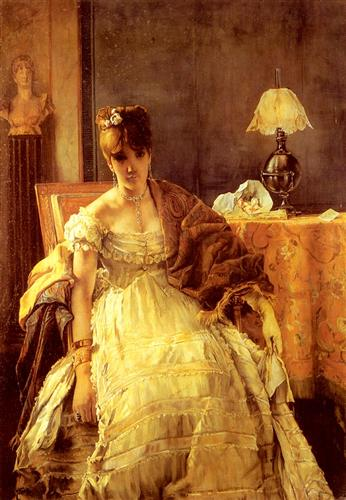Imagine a narrative for the woman in the painting. What might her story be? Evelyn, a young noblewoman of the late 19th century, sat in the familiar comfort of her drawing-room, absorbed in silent contemplation. The ornate dress she wore was not just a symbol of her wealth but of her standing within the intricate social tapestry of her time. As the daylight dimmed and the golden glow of the lamp filled the room, memories of traveling through Europe, meeting artists, philosophers, and even royalty, gently flowed through her mind. She was a figure caught at the crossroads of duty and personal longing, each fold of her dress, each piece of jewelry, a testament to a life lived amidst grandeur but also profound introspection. Evelyn's poised posture, the luxurious surroundings, and the reserved yet profound look in her eyes hint at a life filled with unspoken stories and a quiet strength. What if the woman in the painting suddenly came to life? How would she react to the modern world? Awakening from the confines of the canvas, Evelyn would step into a world vastly different from her own. The initial bewilderment would soon give way to fascination as she witnessed the advancements in technology, fashion, and social norms. She would be intrigued by the freedom and independence enjoyed by women, the pace of life, and the array of opportunities available beyond the domestic sphere. However, she might also feel a pang of nostalgia for the grace and decorum of her era, finding solace in places that still preserved historical charm. As she gradually adapted, her unique blend of old-world knowledge and new-world curiosity would make her a bridge between two very different, yet intrinsically connected, times. 